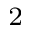Convert formula to latex. <formula><loc_0><loc_0><loc_500><loc_500>_ { 2 }</formula> 